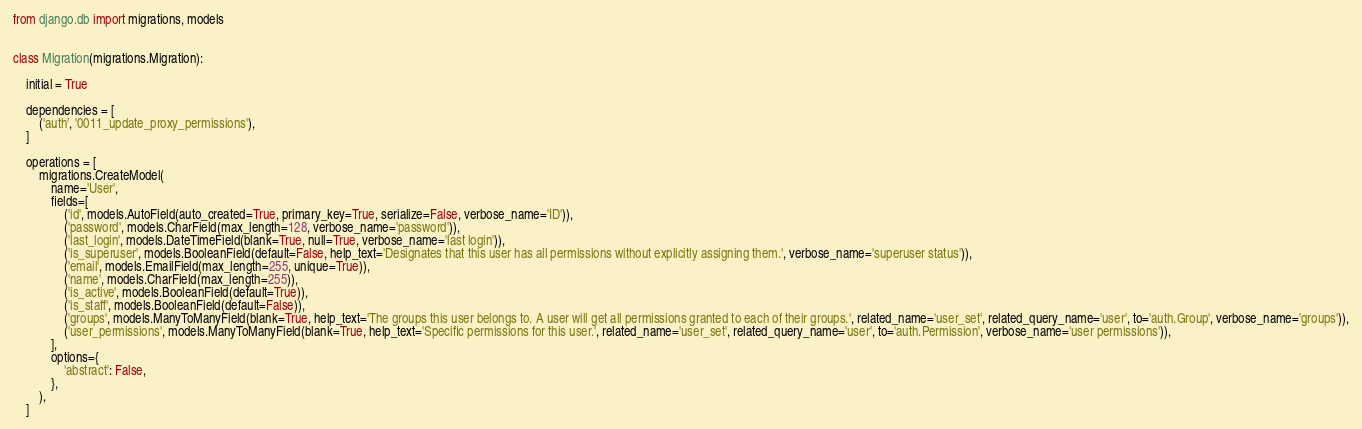Convert code to text. <code><loc_0><loc_0><loc_500><loc_500><_Python_>from django.db import migrations, models


class Migration(migrations.Migration):

    initial = True

    dependencies = [
        ('auth', '0011_update_proxy_permissions'),
    ]

    operations = [
        migrations.CreateModel(
            name='User',
            fields=[
                ('id', models.AutoField(auto_created=True, primary_key=True, serialize=False, verbose_name='ID')),
                ('password', models.CharField(max_length=128, verbose_name='password')),
                ('last_login', models.DateTimeField(blank=True, null=True, verbose_name='last login')),
                ('is_superuser', models.BooleanField(default=False, help_text='Designates that this user has all permissions without explicitly assigning them.', verbose_name='superuser status')),
                ('email', models.EmailField(max_length=255, unique=True)),
                ('name', models.CharField(max_length=255)),
                ('is_active', models.BooleanField(default=True)),
                ('is_staff', models.BooleanField(default=False)),
                ('groups', models.ManyToManyField(blank=True, help_text='The groups this user belongs to. A user will get all permissions granted to each of their groups.', related_name='user_set', related_query_name='user', to='auth.Group', verbose_name='groups')),
                ('user_permissions', models.ManyToManyField(blank=True, help_text='Specific permissions for this user.', related_name='user_set', related_query_name='user', to='auth.Permission', verbose_name='user permissions')),
            ],
            options={
                'abstract': False,
            },
        ),
    ]
</code> 